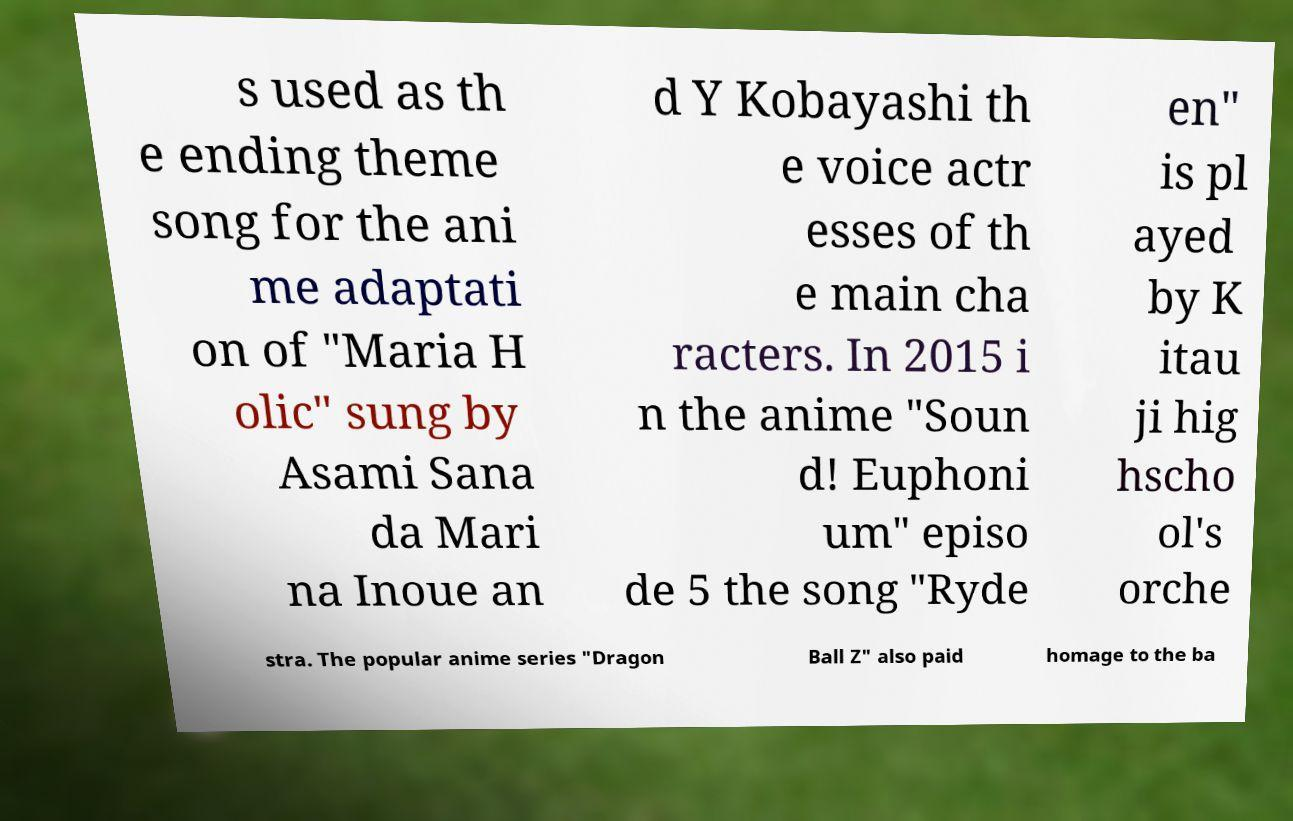Can you read and provide the text displayed in the image?This photo seems to have some interesting text. Can you extract and type it out for me? s used as th e ending theme song for the ani me adaptati on of "Maria H olic" sung by Asami Sana da Mari na Inoue an d Y Kobayashi th e voice actr esses of th e main cha racters. In 2015 i n the anime "Soun d! Euphoni um" episo de 5 the song "Ryde en" is pl ayed by K itau ji hig hscho ol's orche stra. The popular anime series "Dragon Ball Z" also paid homage to the ba 